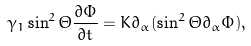Convert formula to latex. <formula><loc_0><loc_0><loc_500><loc_500>\gamma _ { 1 } \sin ^ { 2 } \Theta \frac { \partial \Phi } { \partial t } = K \partial _ { \alpha } ( \sin ^ { 2 } \Theta \partial _ { \alpha } \Phi ) ,</formula> 